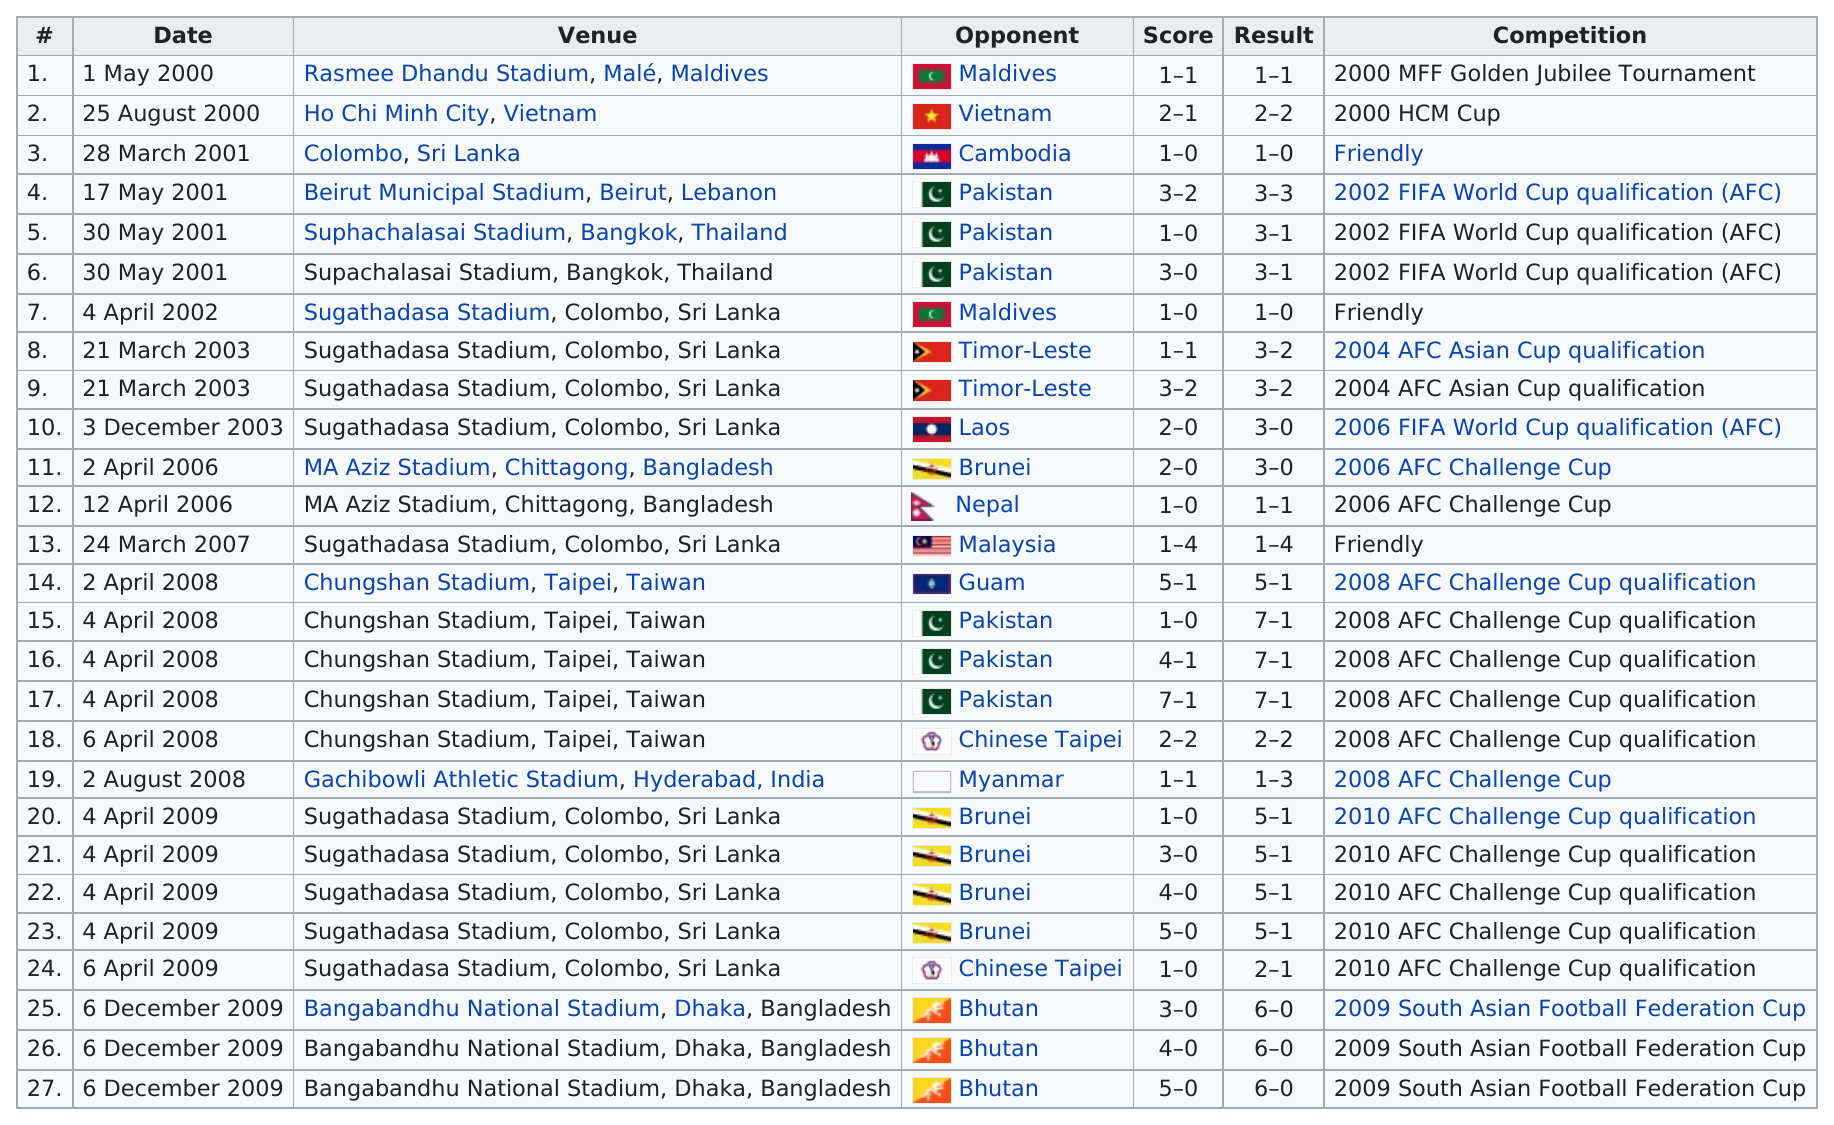Identify some key points in this picture. The Chungshan Stadium in Taipei, Taiwan holds the largest result. Out of the competitions that were played in the same location as their opponent's home ground, a total of 2 were encountered. On April 4, 2008, this player faced Guam before facing Pakistan. The individual played a person in their first friendly game that was hosted by Cambodia. April and December had the most competitions played. 